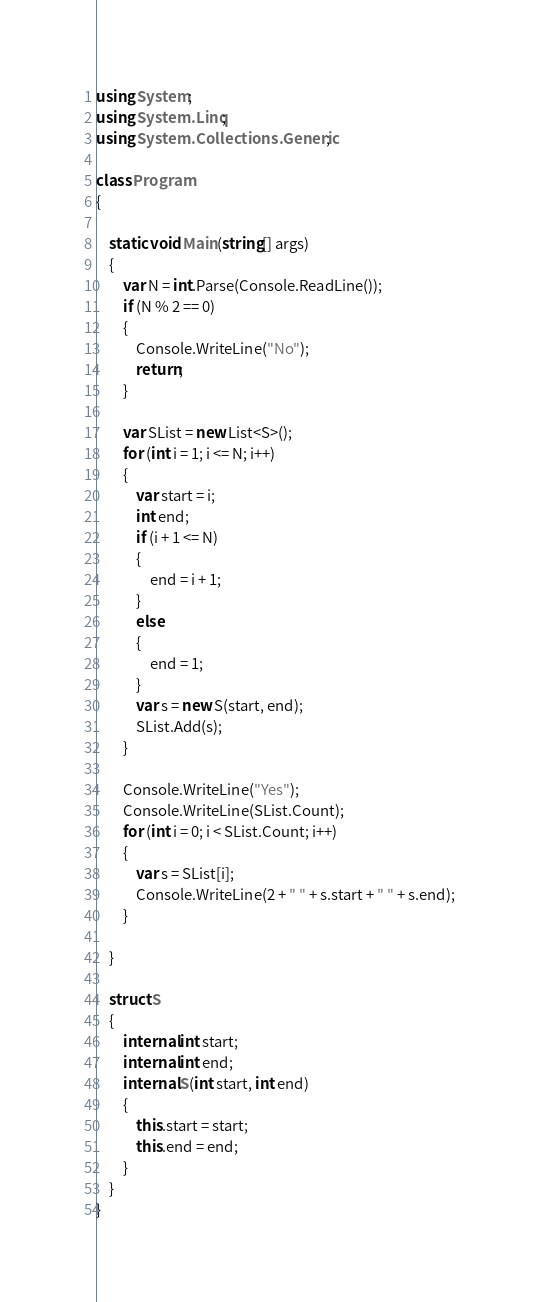<code> <loc_0><loc_0><loc_500><loc_500><_C#_>using System;
using System.Linq;
using System.Collections.Generic;

class Program
{

    static void Main(string[] args)
    {
        var N = int.Parse(Console.ReadLine());
        if (N % 2 == 0)
        {
            Console.WriteLine("No");
            return;
        }

        var SList = new List<S>();
        for (int i = 1; i <= N; i++)
        {
            var start = i;
            int end;
            if (i + 1 <= N)
            {
                end = i + 1;
            }
            else
            {
                end = 1;
            }
            var s = new S(start, end);
            SList.Add(s);
        }

        Console.WriteLine("Yes");
        Console.WriteLine(SList.Count);
        for (int i = 0; i < SList.Count; i++)
        {
            var s = SList[i];
            Console.WriteLine(2 + " " + s.start + " " + s.end);
        }

    }

    struct S
    {
        internal int start;
        internal int end;
        internal S(int start, int end)
        {
            this.start = start;
            this.end = end;
        }
    }
}

</code> 